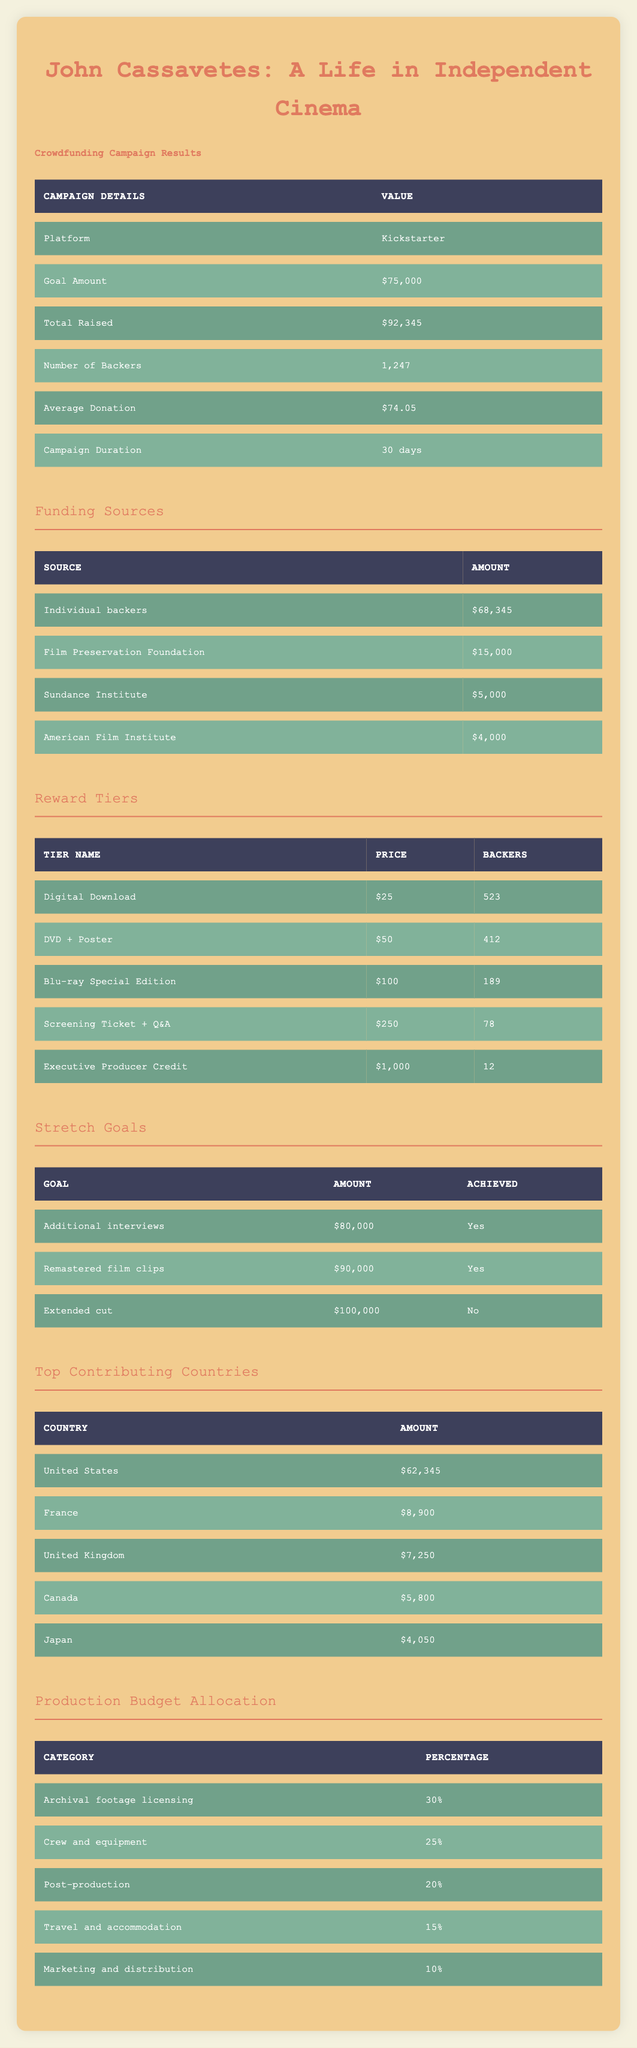What is the total amount raised for the campaign? The table specifically lists the "Total Raised" under the "Campaign Details" section, which is directly stated as $92,345.
Answer: $92,345 How many backers contributed to the campaign? The "Number of Backers" is also provided in the "Campaign Details" section, showing the value of 1,247.
Answer: 1,247 What was the average donation amount? The "Average Donation" shown in the table indicates the average value that backers contributed, which is $74.05.
Answer: $74.05 What percentage of the budget is allocated to archival footage licensing? The specific category "Archival footage licensing" in the "Production Budget Allocation" section indicates that 30% of the budget is allocated to this category.
Answer: 30% Did the campaign achieve its stretch goal for an extended cut? Checking the "Stretch Goals" section, we find that the "Extended cut" goal was listed as not achieved (No).
Answer: No Which funding source contributed the most to the campaign? Looking at the "Funding Sources" section, "Individual backers" contributed the highest amount of $68,345 compared to other sources listed.
Answer: Individual backers What is the total amount received from international backers (France, UK, Canada, Japan)? We sum the amounts from the relevant countries: France ($8,900), UK ($7,250), Canada ($5,800), and Japan ($4,050). The total calculation is $8,900 + $7,250 + $5,800 + $4,050 = $26,000.
Answer: $26,000 Which reward tier had the least number of backers? In the "Reward Tiers" table, the "Executive Producer Credit" tier has the least number of backers listed at 12.
Answer: Executive Producer Credit If the campaign were to reach the extended cut goal, how much more would need to be raised? The "Extended cut" goal is $100,000 and the amount already raised is $92,345. To find out how much more would be needed, subtract the total raised from the goal: $100,000 - $92,345 = $7,655.
Answer: $7,655 What percentage of total raised funds comes from individual backers? The total raised is $92,345 and individual backers contributed $68,345. To find the percentage, divide the contribution by the total raised: ($68,345 / $92,345) * 100 = 73.9%.
Answer: 73.9% 